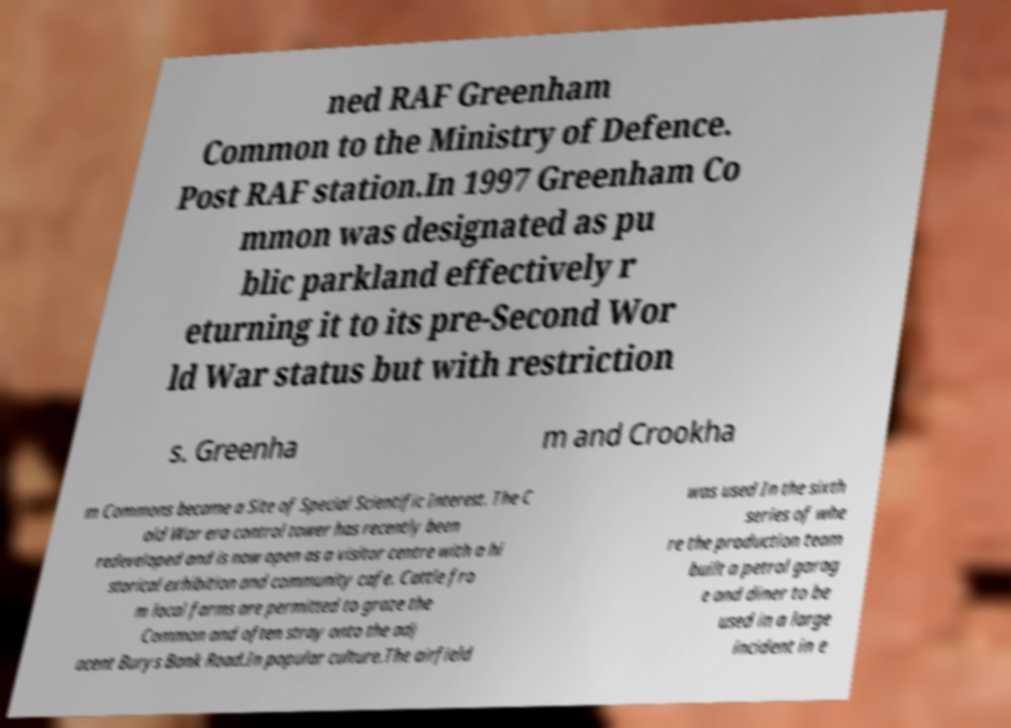Please identify and transcribe the text found in this image. ned RAF Greenham Common to the Ministry of Defence. Post RAF station.In 1997 Greenham Co mmon was designated as pu blic parkland effectively r eturning it to its pre-Second Wor ld War status but with restriction s. Greenha m and Crookha m Commons became a Site of Special Scientific Interest. The C old War era control tower has recently been redeveloped and is now open as a visitor centre with a hi storical exhibition and community cafe. Cattle fro m local farms are permitted to graze the Common and often stray onto the adj acent Burys Bank Road.In popular culture.The airfield was used In the sixth series of whe re the production team built a petrol garag e and diner to be used in a large incident in e 